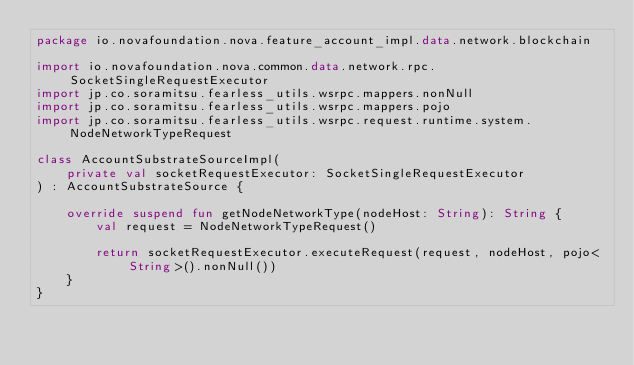Convert code to text. <code><loc_0><loc_0><loc_500><loc_500><_Kotlin_>package io.novafoundation.nova.feature_account_impl.data.network.blockchain

import io.novafoundation.nova.common.data.network.rpc.SocketSingleRequestExecutor
import jp.co.soramitsu.fearless_utils.wsrpc.mappers.nonNull
import jp.co.soramitsu.fearless_utils.wsrpc.mappers.pojo
import jp.co.soramitsu.fearless_utils.wsrpc.request.runtime.system.NodeNetworkTypeRequest

class AccountSubstrateSourceImpl(
    private val socketRequestExecutor: SocketSingleRequestExecutor
) : AccountSubstrateSource {

    override suspend fun getNodeNetworkType(nodeHost: String): String {
        val request = NodeNetworkTypeRequest()

        return socketRequestExecutor.executeRequest(request, nodeHost, pojo<String>().nonNull())
    }
}
</code> 